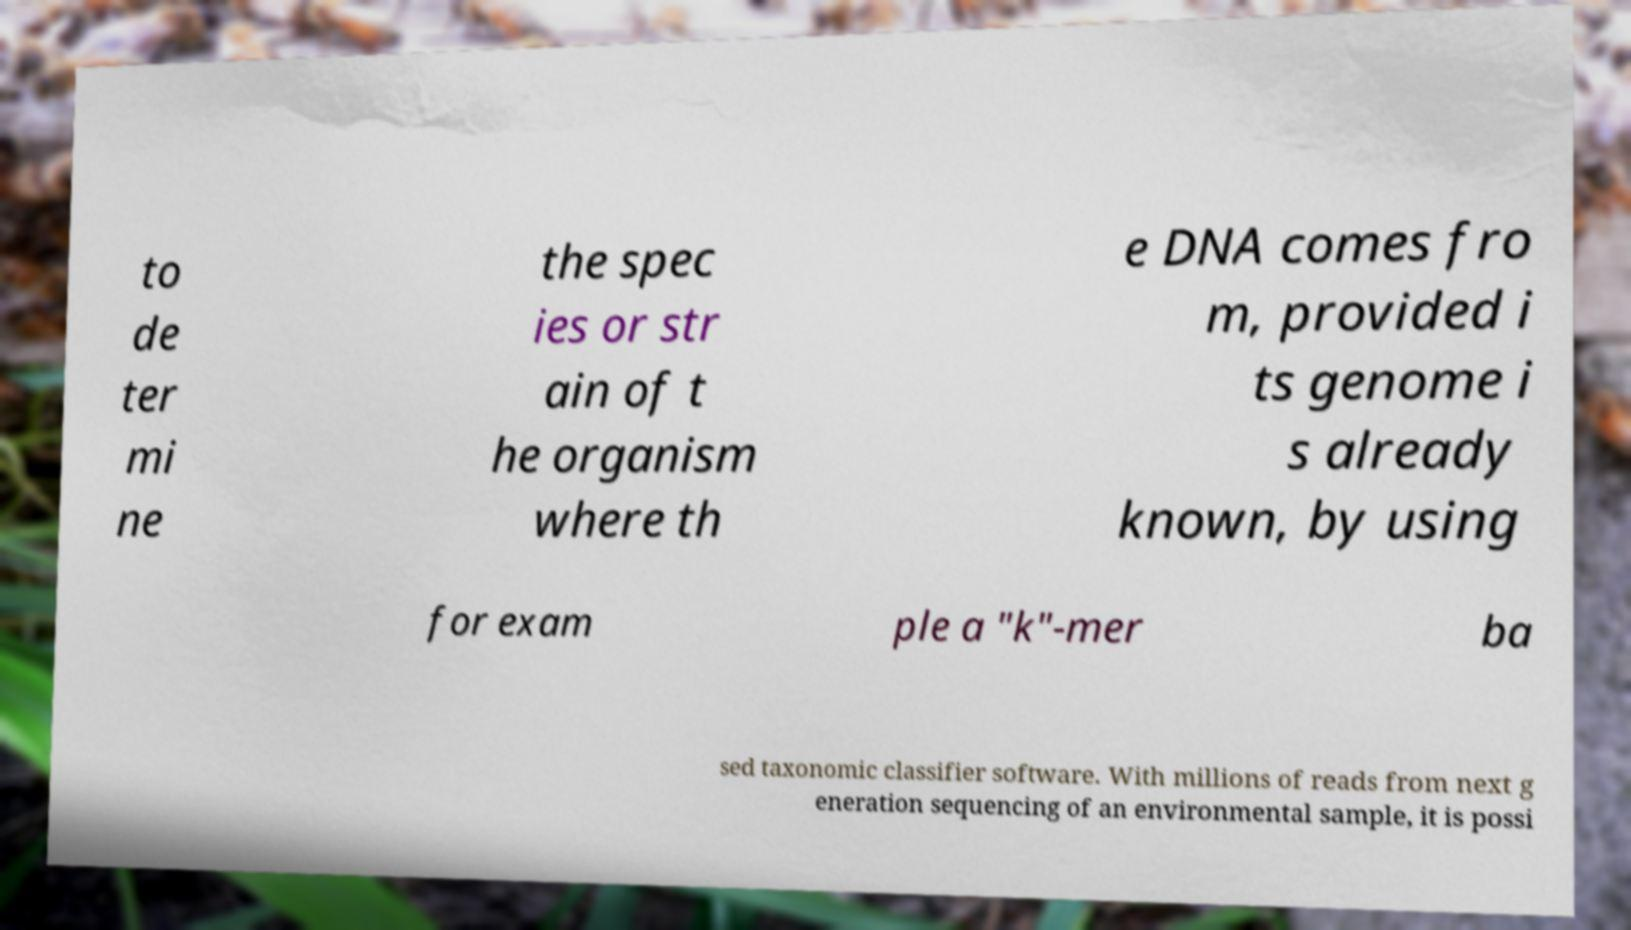There's text embedded in this image that I need extracted. Can you transcribe it verbatim? to de ter mi ne the spec ies or str ain of t he organism where th e DNA comes fro m, provided i ts genome i s already known, by using for exam ple a "k"-mer ba sed taxonomic classifier software. With millions of reads from next g eneration sequencing of an environmental sample, it is possi 